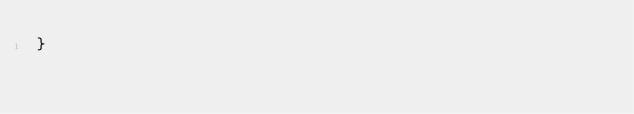<code> <loc_0><loc_0><loc_500><loc_500><_Go_>}
</code> 